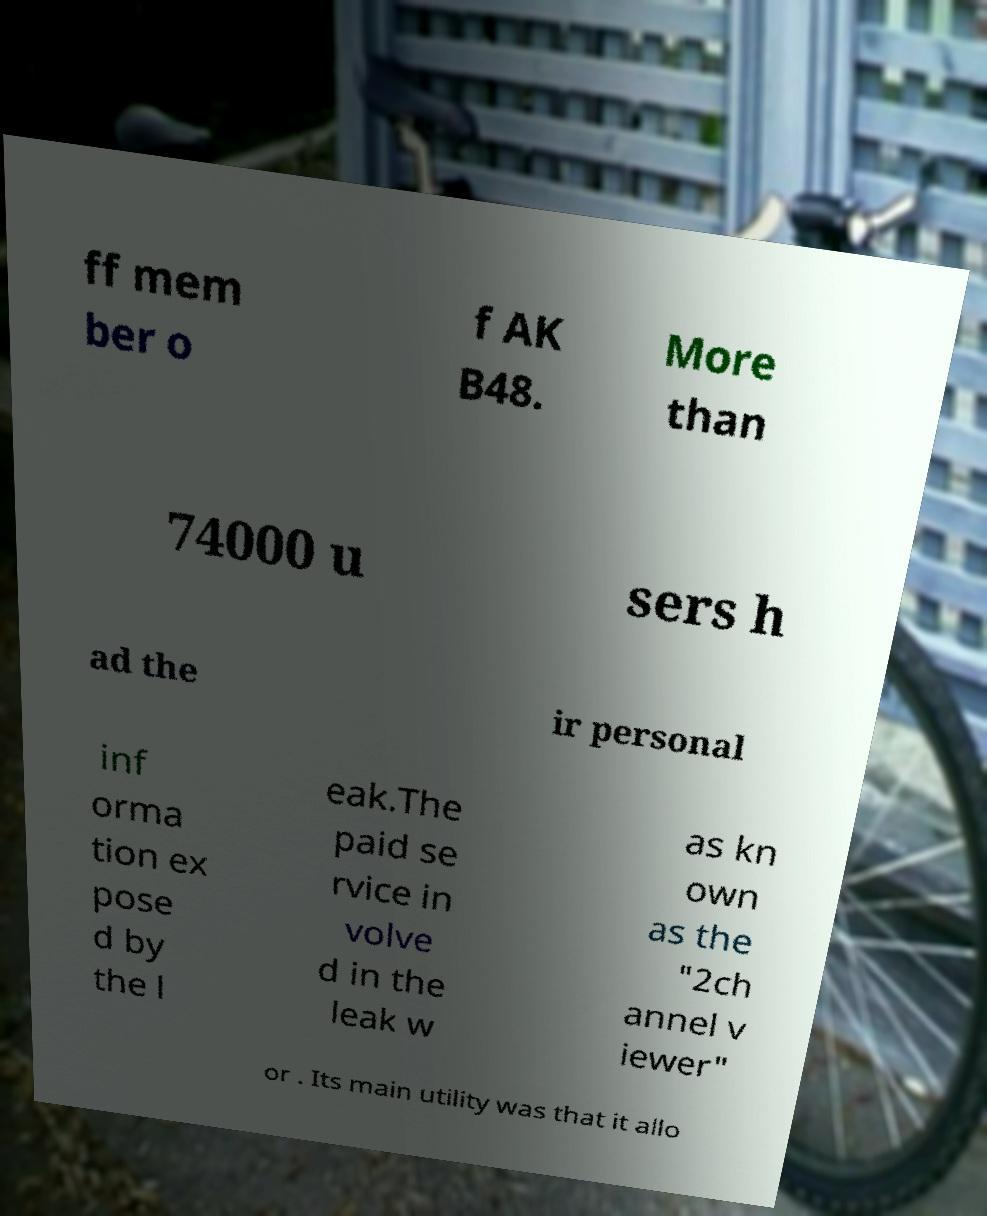Could you assist in decoding the text presented in this image and type it out clearly? ff mem ber o f AK B48. More than 74000 u sers h ad the ir personal inf orma tion ex pose d by the l eak.The paid se rvice in volve d in the leak w as kn own as the "2ch annel v iewer" or . Its main utility was that it allo 